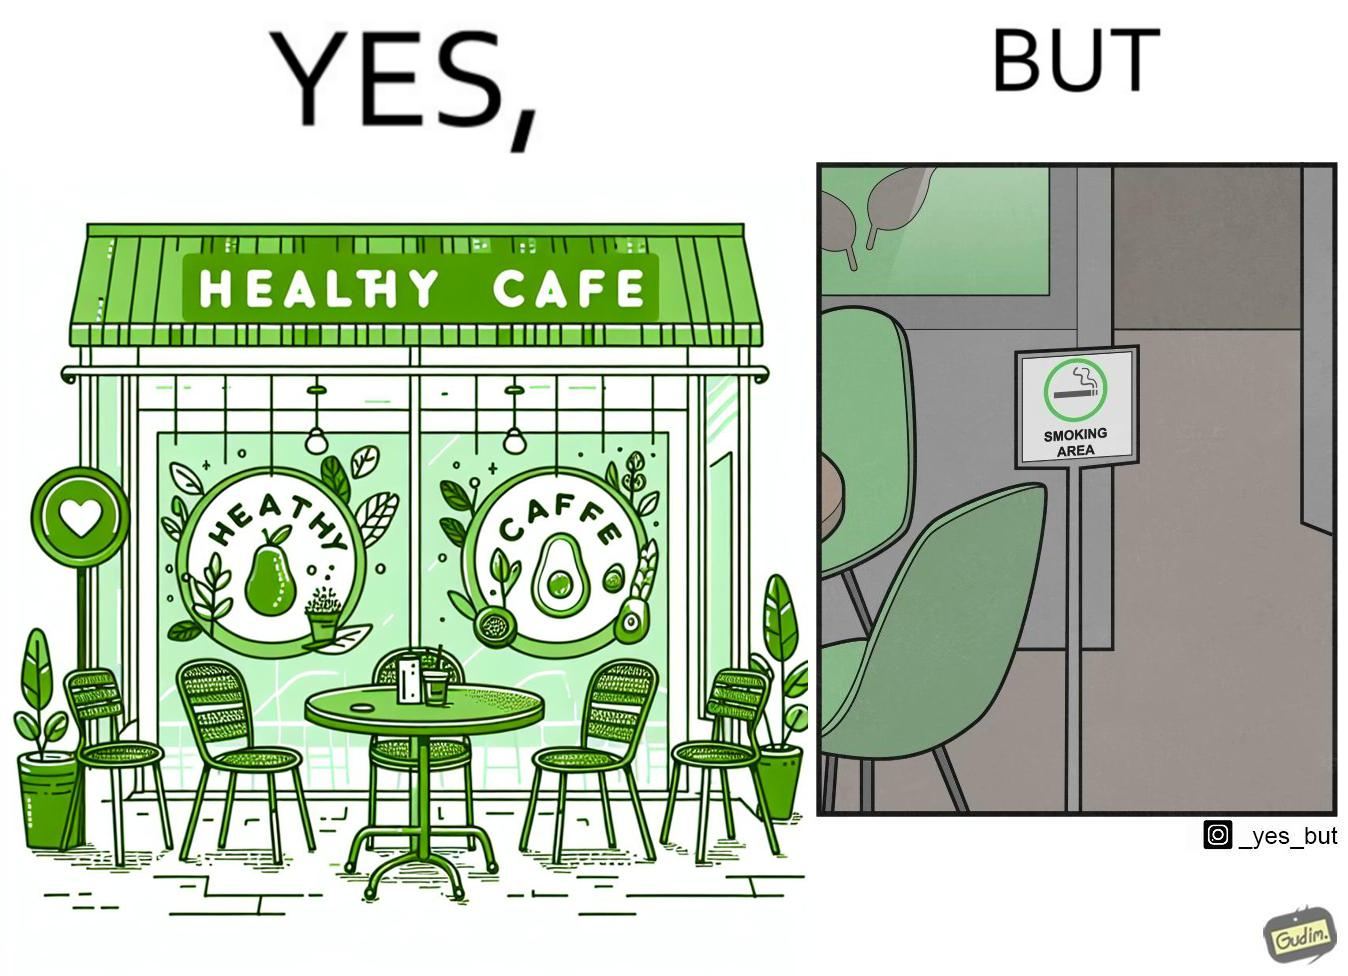Would you classify this image as satirical? Yes, this image is satirical. 